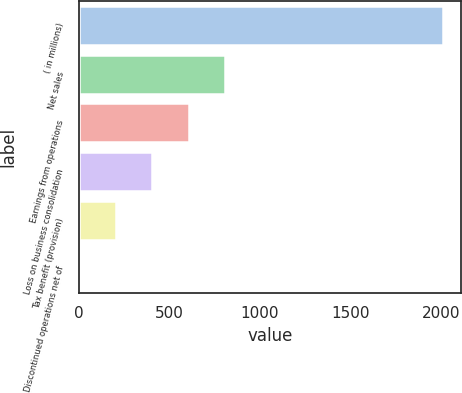Convert chart to OTSL. <chart><loc_0><loc_0><loc_500><loc_500><bar_chart><fcel>( in millions)<fcel>Net sales<fcel>Earnings from operations<fcel>Loss on business consolidation<fcel>Tax benefit (provision)<fcel>Discontinued operations net of<nl><fcel>2008<fcel>805.96<fcel>605.62<fcel>405.28<fcel>204.94<fcel>4.6<nl></chart> 